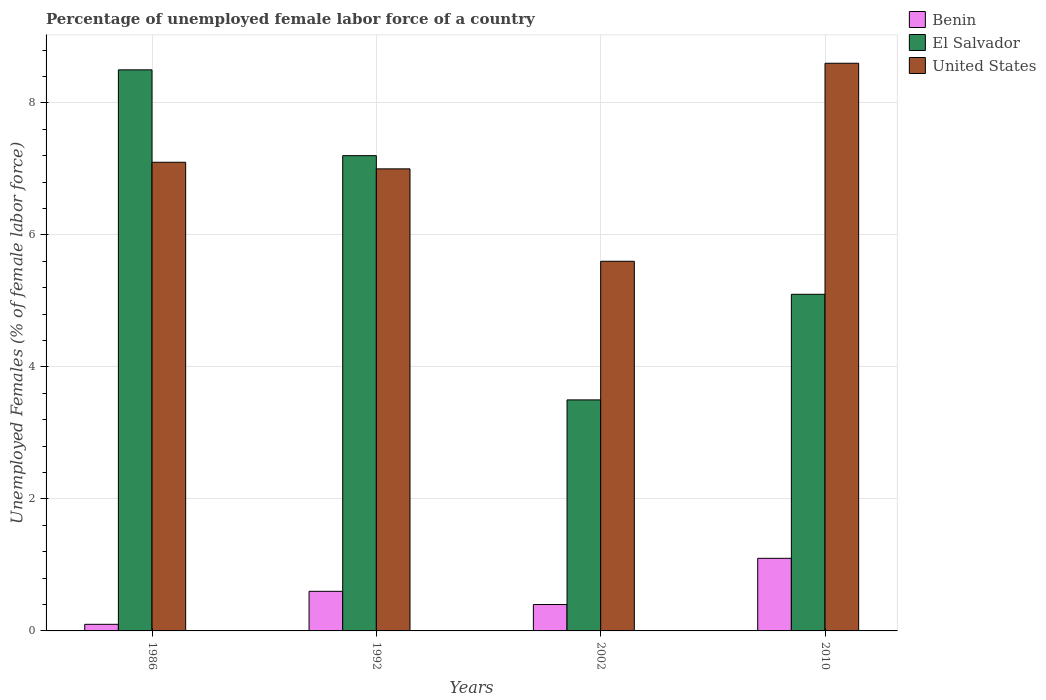How many different coloured bars are there?
Provide a short and direct response. 3. How many groups of bars are there?
Provide a short and direct response. 4. Are the number of bars on each tick of the X-axis equal?
Offer a very short reply. Yes. How many bars are there on the 3rd tick from the left?
Make the answer very short. 3. What is the label of the 1st group of bars from the left?
Your answer should be very brief. 1986. What is the percentage of unemployed female labor force in El Salvador in 2010?
Your answer should be very brief. 5.1. Across all years, what is the maximum percentage of unemployed female labor force in El Salvador?
Your answer should be compact. 8.5. In which year was the percentage of unemployed female labor force in El Salvador maximum?
Give a very brief answer. 1986. What is the total percentage of unemployed female labor force in Benin in the graph?
Your response must be concise. 2.2. What is the difference between the percentage of unemployed female labor force in Benin in 1986 and that in 2010?
Offer a terse response. -1. What is the difference between the percentage of unemployed female labor force in Benin in 1992 and the percentage of unemployed female labor force in El Salvador in 2002?
Your answer should be compact. -2.9. What is the average percentage of unemployed female labor force in United States per year?
Offer a very short reply. 7.08. In the year 1986, what is the difference between the percentage of unemployed female labor force in United States and percentage of unemployed female labor force in Benin?
Your response must be concise. 7. In how many years, is the percentage of unemployed female labor force in Benin greater than 4.8 %?
Your answer should be compact. 0. What is the ratio of the percentage of unemployed female labor force in United States in 1986 to that in 2010?
Your answer should be compact. 0.83. What is the difference between the highest and the second highest percentage of unemployed female labor force in El Salvador?
Provide a succinct answer. 1.3. Is the sum of the percentage of unemployed female labor force in United States in 2002 and 2010 greater than the maximum percentage of unemployed female labor force in El Salvador across all years?
Offer a very short reply. Yes. What does the 1st bar from the left in 1992 represents?
Keep it short and to the point. Benin. What does the 3rd bar from the right in 2010 represents?
Offer a very short reply. Benin. How many years are there in the graph?
Keep it short and to the point. 4. Are the values on the major ticks of Y-axis written in scientific E-notation?
Offer a terse response. No. How many legend labels are there?
Your answer should be very brief. 3. What is the title of the graph?
Your answer should be very brief. Percentage of unemployed female labor force of a country. Does "Vanuatu" appear as one of the legend labels in the graph?
Offer a very short reply. No. What is the label or title of the Y-axis?
Provide a short and direct response. Unemployed Females (% of female labor force). What is the Unemployed Females (% of female labor force) of Benin in 1986?
Make the answer very short. 0.1. What is the Unemployed Females (% of female labor force) in United States in 1986?
Your response must be concise. 7.1. What is the Unemployed Females (% of female labor force) of Benin in 1992?
Provide a succinct answer. 0.6. What is the Unemployed Females (% of female labor force) of El Salvador in 1992?
Make the answer very short. 7.2. What is the Unemployed Females (% of female labor force) in Benin in 2002?
Ensure brevity in your answer.  0.4. What is the Unemployed Females (% of female labor force) of United States in 2002?
Provide a short and direct response. 5.6. What is the Unemployed Females (% of female labor force) in Benin in 2010?
Your answer should be compact. 1.1. What is the Unemployed Females (% of female labor force) in El Salvador in 2010?
Give a very brief answer. 5.1. What is the Unemployed Females (% of female labor force) in United States in 2010?
Make the answer very short. 8.6. Across all years, what is the maximum Unemployed Females (% of female labor force) in Benin?
Provide a short and direct response. 1.1. Across all years, what is the maximum Unemployed Females (% of female labor force) in United States?
Offer a terse response. 8.6. Across all years, what is the minimum Unemployed Females (% of female labor force) of Benin?
Your answer should be very brief. 0.1. Across all years, what is the minimum Unemployed Females (% of female labor force) of El Salvador?
Offer a terse response. 3.5. Across all years, what is the minimum Unemployed Females (% of female labor force) in United States?
Ensure brevity in your answer.  5.6. What is the total Unemployed Females (% of female labor force) in El Salvador in the graph?
Make the answer very short. 24.3. What is the total Unemployed Females (% of female labor force) in United States in the graph?
Provide a short and direct response. 28.3. What is the difference between the Unemployed Females (% of female labor force) in Benin in 1986 and that in 1992?
Make the answer very short. -0.5. What is the difference between the Unemployed Females (% of female labor force) of United States in 1986 and that in 1992?
Your answer should be very brief. 0.1. What is the difference between the Unemployed Females (% of female labor force) of El Salvador in 1986 and that in 2010?
Provide a short and direct response. 3.4. What is the difference between the Unemployed Females (% of female labor force) of United States in 1986 and that in 2010?
Make the answer very short. -1.5. What is the difference between the Unemployed Females (% of female labor force) of Benin in 1992 and that in 2002?
Provide a short and direct response. 0.2. What is the difference between the Unemployed Females (% of female labor force) of El Salvador in 1992 and that in 2002?
Offer a very short reply. 3.7. What is the difference between the Unemployed Females (% of female labor force) of El Salvador in 1992 and that in 2010?
Your response must be concise. 2.1. What is the difference between the Unemployed Females (% of female labor force) of United States in 1992 and that in 2010?
Give a very brief answer. -1.6. What is the difference between the Unemployed Females (% of female labor force) of Benin in 2002 and that in 2010?
Offer a very short reply. -0.7. What is the difference between the Unemployed Females (% of female labor force) of El Salvador in 2002 and that in 2010?
Provide a succinct answer. -1.6. What is the difference between the Unemployed Females (% of female labor force) of United States in 2002 and that in 2010?
Offer a terse response. -3. What is the difference between the Unemployed Females (% of female labor force) in Benin in 1986 and the Unemployed Females (% of female labor force) in United States in 1992?
Provide a succinct answer. -6.9. What is the difference between the Unemployed Females (% of female labor force) in El Salvador in 1986 and the Unemployed Females (% of female labor force) in United States in 2002?
Make the answer very short. 2.9. What is the difference between the Unemployed Females (% of female labor force) of Benin in 1986 and the Unemployed Females (% of female labor force) of United States in 2010?
Keep it short and to the point. -8.5. What is the difference between the Unemployed Females (% of female labor force) in Benin in 1992 and the Unemployed Females (% of female labor force) in El Salvador in 2002?
Your answer should be very brief. -2.9. What is the difference between the Unemployed Females (% of female labor force) in Benin in 1992 and the Unemployed Females (% of female labor force) in United States in 2002?
Give a very brief answer. -5. What is the difference between the Unemployed Females (% of female labor force) of El Salvador in 1992 and the Unemployed Females (% of female labor force) of United States in 2002?
Provide a short and direct response. 1.6. What is the difference between the Unemployed Females (% of female labor force) of El Salvador in 1992 and the Unemployed Females (% of female labor force) of United States in 2010?
Give a very brief answer. -1.4. What is the difference between the Unemployed Females (% of female labor force) of Benin in 2002 and the Unemployed Females (% of female labor force) of El Salvador in 2010?
Offer a terse response. -4.7. What is the difference between the Unemployed Females (% of female labor force) in Benin in 2002 and the Unemployed Females (% of female labor force) in United States in 2010?
Provide a succinct answer. -8.2. What is the difference between the Unemployed Females (% of female labor force) in El Salvador in 2002 and the Unemployed Females (% of female labor force) in United States in 2010?
Your answer should be compact. -5.1. What is the average Unemployed Females (% of female labor force) of Benin per year?
Make the answer very short. 0.55. What is the average Unemployed Females (% of female labor force) of El Salvador per year?
Give a very brief answer. 6.08. What is the average Unemployed Females (% of female labor force) of United States per year?
Your answer should be compact. 7.08. In the year 1986, what is the difference between the Unemployed Females (% of female labor force) in Benin and Unemployed Females (% of female labor force) in United States?
Your answer should be compact. -7. In the year 1992, what is the difference between the Unemployed Females (% of female labor force) of Benin and Unemployed Females (% of female labor force) of United States?
Provide a succinct answer. -6.4. In the year 2002, what is the difference between the Unemployed Females (% of female labor force) of Benin and Unemployed Females (% of female labor force) of United States?
Ensure brevity in your answer.  -5.2. What is the ratio of the Unemployed Females (% of female labor force) of El Salvador in 1986 to that in 1992?
Ensure brevity in your answer.  1.18. What is the ratio of the Unemployed Females (% of female labor force) in United States in 1986 to that in 1992?
Keep it short and to the point. 1.01. What is the ratio of the Unemployed Females (% of female labor force) in El Salvador in 1986 to that in 2002?
Keep it short and to the point. 2.43. What is the ratio of the Unemployed Females (% of female labor force) in United States in 1986 to that in 2002?
Give a very brief answer. 1.27. What is the ratio of the Unemployed Females (% of female labor force) of Benin in 1986 to that in 2010?
Give a very brief answer. 0.09. What is the ratio of the Unemployed Females (% of female labor force) of El Salvador in 1986 to that in 2010?
Your answer should be very brief. 1.67. What is the ratio of the Unemployed Females (% of female labor force) in United States in 1986 to that in 2010?
Your response must be concise. 0.83. What is the ratio of the Unemployed Females (% of female labor force) of El Salvador in 1992 to that in 2002?
Give a very brief answer. 2.06. What is the ratio of the Unemployed Females (% of female labor force) in United States in 1992 to that in 2002?
Keep it short and to the point. 1.25. What is the ratio of the Unemployed Females (% of female labor force) of Benin in 1992 to that in 2010?
Provide a succinct answer. 0.55. What is the ratio of the Unemployed Females (% of female labor force) in El Salvador in 1992 to that in 2010?
Your answer should be very brief. 1.41. What is the ratio of the Unemployed Females (% of female labor force) of United States in 1992 to that in 2010?
Make the answer very short. 0.81. What is the ratio of the Unemployed Females (% of female labor force) in Benin in 2002 to that in 2010?
Offer a very short reply. 0.36. What is the ratio of the Unemployed Females (% of female labor force) in El Salvador in 2002 to that in 2010?
Your answer should be very brief. 0.69. What is the ratio of the Unemployed Females (% of female labor force) of United States in 2002 to that in 2010?
Your answer should be compact. 0.65. What is the difference between the highest and the second highest Unemployed Females (% of female labor force) of Benin?
Keep it short and to the point. 0.5. What is the difference between the highest and the second highest Unemployed Females (% of female labor force) of El Salvador?
Ensure brevity in your answer.  1.3. What is the difference between the highest and the lowest Unemployed Females (% of female labor force) of United States?
Ensure brevity in your answer.  3. 